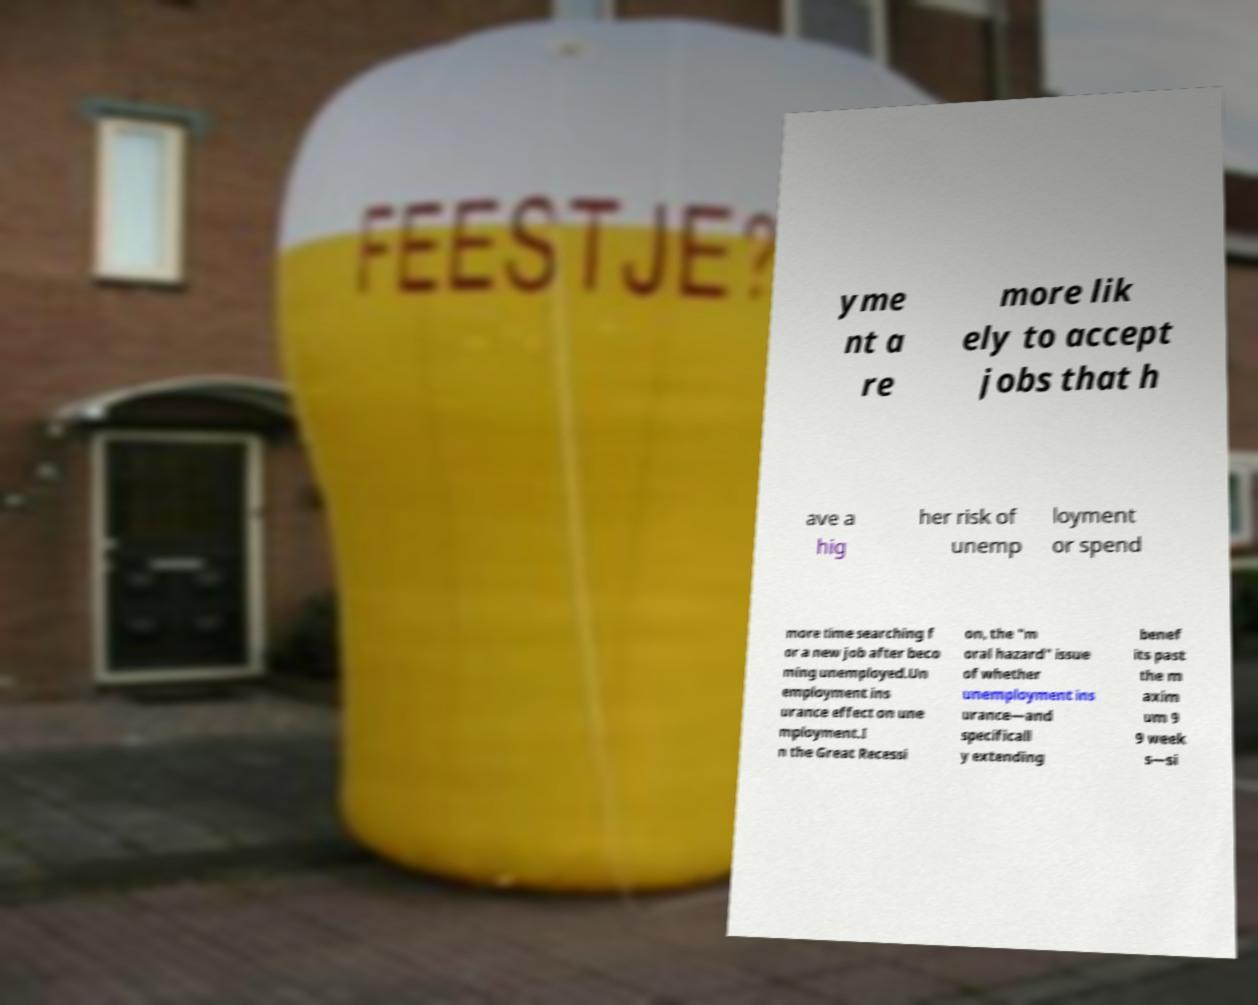Please read and relay the text visible in this image. What does it say? yme nt a re more lik ely to accept jobs that h ave a hig her risk of unemp loyment or spend more time searching f or a new job after beco ming unemployed.Un employment ins urance effect on une mployment.I n the Great Recessi on, the "m oral hazard" issue of whether unemployment ins urance—and specificall y extending benef its past the m axim um 9 9 week s—si 